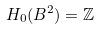Convert formula to latex. <formula><loc_0><loc_0><loc_500><loc_500>H _ { 0 } ( B ^ { 2 } ) = \mathbb { Z }</formula> 